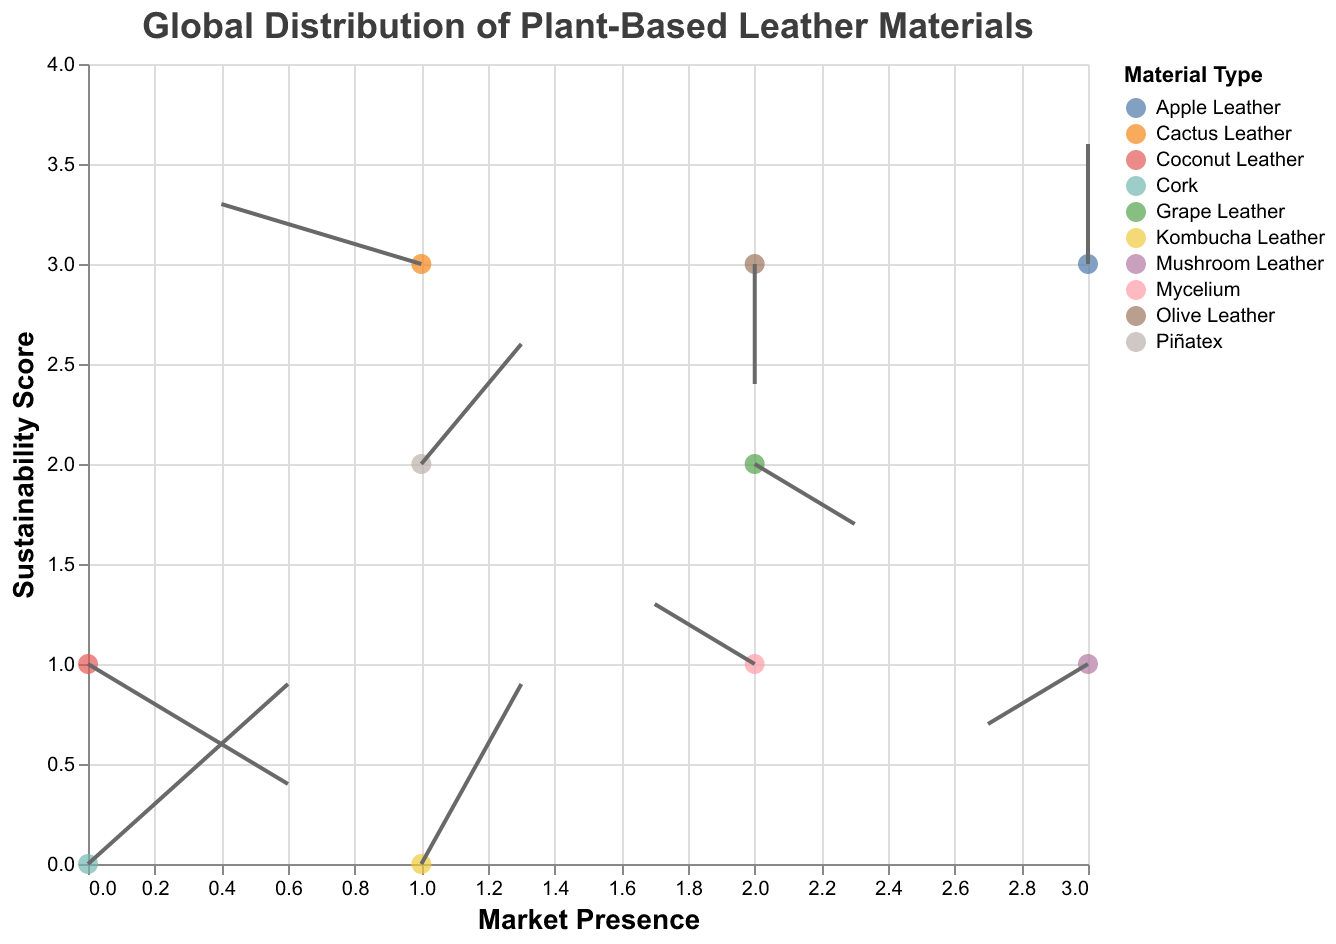What type of data is displayed in the figure? The title of the figure "Global Distribution of Plant-Based Leather Materials" indicates that the data represents the distribution of different plant-based leather materials and their growth vectors globally.
Answer: Global distribution of plant-based leather materials Which material has the highest sustainability score and what is its score? By looking at the y-axis, which represents the sustainability score, we see that "Cactus Leather" has the highest y value at 3.
Answer: Cactus Leather, 3 How many materials have a negative growth vector in the horizontal direction (u)? Check for the materials whose growth vector (u) is negative. According to the data, Mycelium, Cactus Leather, and Mushroom Leather have negative u values.
Answer: 3 What is the vertical growth vector (v) for Apple Leather and how does it compare to Kombucha Leather? The data shows that Apple Leather has a vertical growth vector (v) of 2, while Kombucha Leather has a vertical growth vector (v) of 3. Comparing the two, Kombucha Leather's vector is larger.
Answer: Apple Leather: 2, Kombucha Leather: 3, Kombucha Leather is larger Which materials have growth vectors that point downwards? Growth vectors pointing downwards have negative v values. Grape Leather, Coconut Leather, Mushroom Leather, and Olive Leather have negative v values.
Answer: Grape Leather, Coconut Leather, Mushroom Leather, Olive Leather What are the market presence and sustainability score for Kombucha Leather? Kombucha Leather's coordinates are given by its (x, y) values. From the data, x = 1 and y = 0.
Answer: Market Presence: 1, Sustainability Score: 0 Which material shows the most significant vertical growth vector and what is this vector's value? The magnitude of vertical growth (v) is shown in the figure. Kombucha Leather and Cork both have the highest v values of 3, hence they show the most significant vertical growth vectors.
Answer: 3 (Kombucha Leather and Cork) How does the market presence and sustainability score of Mushroom Leather compare with Coconut Leather? Mushroom Leather has coordinates (3, 1), and Coconut Leather has coordinates (0, 1). Comparing both, they have the same sustainability score (1), but Mushroom Leather has higher market presence (3 vs. 0).
Answer: Same sustainability score; Mushroom Leather has higher market presence Which material starts at (2, 1) and what is its growth vector? From the data or the plot, we see that Mycelium is the material that starts at the coordinates (2, 1). Its growth vector is (-1, 1).
Answer: Mycelium, growth vector: (-1, 1) What can you infer about Coconut Leather's sustainability trend based on its vector? Coconut Leather's vector (u=2, v=-2) indicates that while it has an upward trend in market presence (positive u), its sustainability score is decreasing (negative v).
Answer: Increasing market presence, decreasing sustainability score 